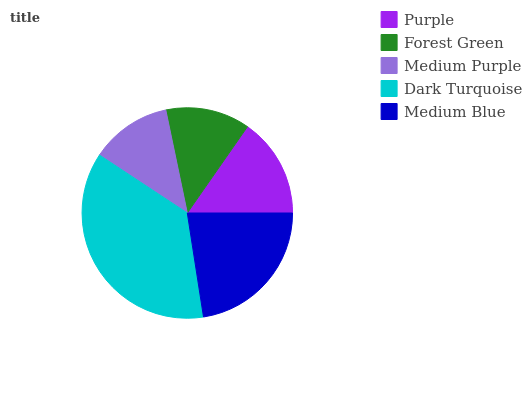Is Medium Purple the minimum?
Answer yes or no. Yes. Is Dark Turquoise the maximum?
Answer yes or no. Yes. Is Forest Green the minimum?
Answer yes or no. No. Is Forest Green the maximum?
Answer yes or no. No. Is Purple greater than Forest Green?
Answer yes or no. Yes. Is Forest Green less than Purple?
Answer yes or no. Yes. Is Forest Green greater than Purple?
Answer yes or no. No. Is Purple less than Forest Green?
Answer yes or no. No. Is Purple the high median?
Answer yes or no. Yes. Is Purple the low median?
Answer yes or no. Yes. Is Medium Blue the high median?
Answer yes or no. No. Is Medium Blue the low median?
Answer yes or no. No. 